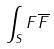<formula> <loc_0><loc_0><loc_500><loc_500>\int _ { S } F \overline { F }</formula> 